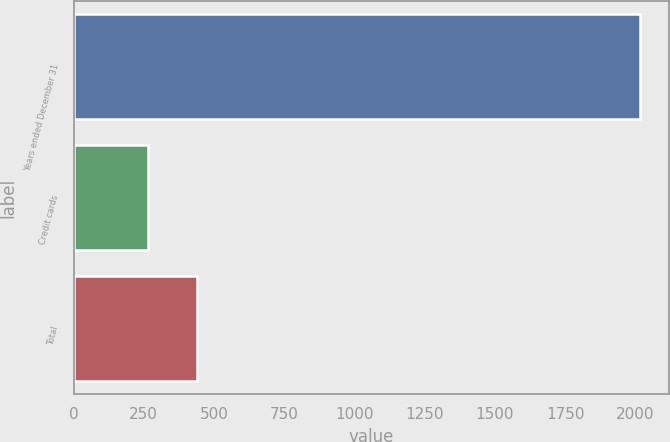Convert chart. <chart><loc_0><loc_0><loc_500><loc_500><bar_chart><fcel>Years ended December 31<fcel>Credit cards<fcel>Total<nl><fcel>2018<fcel>266<fcel>441.2<nl></chart> 